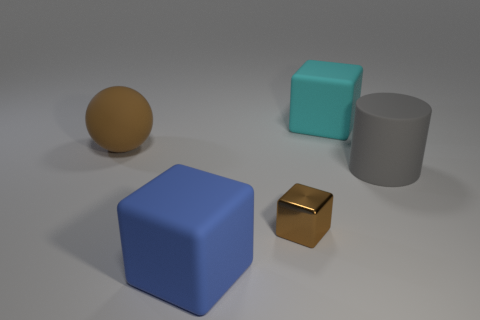Can you describe the texture of the objects in this image? Certainly! The blue cube and the teal cube exhibit a smooth surface, whereas the small brown block appears to have a shiny, reflective finish, similar to polished metal. The rubber sphere, with its soft matte finish, suggests that it might have a slightly rough texture if touched. 